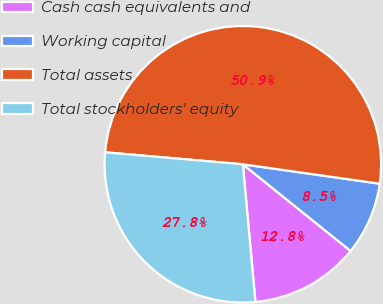Convert chart to OTSL. <chart><loc_0><loc_0><loc_500><loc_500><pie_chart><fcel>Cash cash equivalents and<fcel>Working capital<fcel>Total assets<fcel>Total stockholders' equity<nl><fcel>12.77%<fcel>8.54%<fcel>50.86%<fcel>27.83%<nl></chart> 